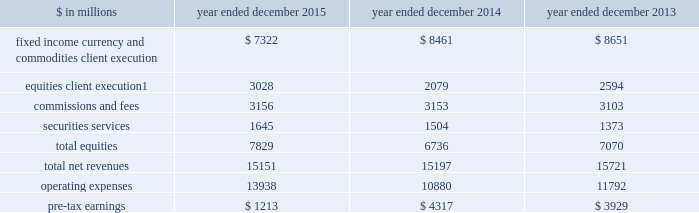The goldman sachs group , inc .
And subsidiaries management 2019s discussion and analysis equities .
Includes client execution activities related to making markets in equity products and commissions and fees from executing and clearing institutional client transactions on major stock , options and futures exchanges worldwide , as well as otc transactions .
Equities also includes our securities services business , which provides financing , securities lending and other prime brokerage services to institutional clients , including hedge funds , mutual funds , pension funds and foundations , and generates revenues primarily in the form of interest rate spreads or fees .
The table below presents the operating results of our institutional client services segment. .
Net revenues related to the americas reinsurance business were $ 317 million for 2013 .
In april 2013 , we completed the sale of a majority stake in our americas reinsurance business and no longer consolidate this business .
2015 versus 2014 .
Net revenues in institutional client services were $ 15.15 billion for 2015 , essentially unchanged compared with 2014 .
Net revenues in fixed income , currency and commodities client execution were $ 7.32 billion for 2015 , 13% ( 13 % ) lower than 2014 .
Excluding a gain of $ 168 million in 2014 related to the extinguishment of certain of our junior subordinated debt , net revenues in fixed income , currency and commodities client execution were 12% ( 12 % ) lower than 2014 , reflecting significantly lower net revenues in mortgages , credit products and commodities .
The decreases in mortgages and credit products reflected challenging market-making conditions and generally low levels of activity during 2015 .
The decline in commodities primarily reflected less favorable market-making conditions compared with 2014 , which included a strong first quarter of 2014 .
These decreases were partially offset by significantly higher net revenues in interest rate products and currencies , reflecting higher volatility levels which contributed to higher client activity levels , particularly during the first quarter of 2015 .
Net revenues in equities were $ 7.83 billion for 2015 , 16% ( 16 % ) higher than 2014 .
Excluding a gain of $ 121 million ( $ 30 million and $ 91 million included in equities client execution and securities services , respectively ) in 2014 related to the extinguishment of certain of our junior subordinated debt , net revenues in equities were 18% ( 18 % ) higher than 2014 , primarily due to significantly higher net revenues in equities client execution across the major regions , reflecting significantly higher results in both derivatives and cash products , and higher net revenues in securities services , reflecting the impact of higher average customer balances and improved securities lending spreads .
Commissions and fees were essentially unchanged compared with 2014 .
The firm elects the fair value option for certain unsecured borrowings .
The fair value net gain attributable to the impact of changes in our credit spreads on these borrowings was $ 255 million ( $ 214 million and $ 41 million related to fixed income , currency and commodities client execution and equities client execution , respectively ) for 2015 , compared with a net gain of $ 144 million ( $ 108 million and $ 36 million related to fixed income , currency and commodities client execution and equities client execution , respectively ) for 2014 .
During 2015 , the operating environment for institutional client services was positively impacted by diverging central bank monetary policies in the united states and the euro area in the first quarter , as increased volatility levels contributed to strong client activity levels in currencies , interest rate products and equity products , and market- making conditions improved .
However , during the remainder of the year , concerns about global growth and uncertainty about the u.s .
Federal reserve 2019s interest rate policy , along with lower global equity prices , widening high-yield credit spreads and declining commodity prices , contributed to lower levels of client activity , particularly in mortgages and credit , and more difficult market-making conditions .
If macroeconomic concerns continue over the long term and activity levels decline , net revenues in institutional client services would likely be negatively impacted .
Operating expenses were $ 13.94 billion for 2015 , 28% ( 28 % ) higher than 2014 , due to significantly higher net provisions for mortgage-related litigation and regulatory matters , partially offset by decreased compensation and benefits expenses .
Pre-tax earnings were $ 1.21 billion in 2015 , 72% ( 72 % ) lower than 2014 .
62 goldman sachs 2015 form 10-k .
What percentage of total net revenues in the institutional client services segment was due to fixed income currency and commodities client execution in 2014? 
Computations: (8461 / 15197)
Answer: 0.55675. The goldman sachs group , inc .
And subsidiaries management 2019s discussion and analysis equities .
Includes client execution activities related to making markets in equity products and commissions and fees from executing and clearing institutional client transactions on major stock , options and futures exchanges worldwide , as well as otc transactions .
Equities also includes our securities services business , which provides financing , securities lending and other prime brokerage services to institutional clients , including hedge funds , mutual funds , pension funds and foundations , and generates revenues primarily in the form of interest rate spreads or fees .
The table below presents the operating results of our institutional client services segment. .
Net revenues related to the americas reinsurance business were $ 317 million for 2013 .
In april 2013 , we completed the sale of a majority stake in our americas reinsurance business and no longer consolidate this business .
2015 versus 2014 .
Net revenues in institutional client services were $ 15.15 billion for 2015 , essentially unchanged compared with 2014 .
Net revenues in fixed income , currency and commodities client execution were $ 7.32 billion for 2015 , 13% ( 13 % ) lower than 2014 .
Excluding a gain of $ 168 million in 2014 related to the extinguishment of certain of our junior subordinated debt , net revenues in fixed income , currency and commodities client execution were 12% ( 12 % ) lower than 2014 , reflecting significantly lower net revenues in mortgages , credit products and commodities .
The decreases in mortgages and credit products reflected challenging market-making conditions and generally low levels of activity during 2015 .
The decline in commodities primarily reflected less favorable market-making conditions compared with 2014 , which included a strong first quarter of 2014 .
These decreases were partially offset by significantly higher net revenues in interest rate products and currencies , reflecting higher volatility levels which contributed to higher client activity levels , particularly during the first quarter of 2015 .
Net revenues in equities were $ 7.83 billion for 2015 , 16% ( 16 % ) higher than 2014 .
Excluding a gain of $ 121 million ( $ 30 million and $ 91 million included in equities client execution and securities services , respectively ) in 2014 related to the extinguishment of certain of our junior subordinated debt , net revenues in equities were 18% ( 18 % ) higher than 2014 , primarily due to significantly higher net revenues in equities client execution across the major regions , reflecting significantly higher results in both derivatives and cash products , and higher net revenues in securities services , reflecting the impact of higher average customer balances and improved securities lending spreads .
Commissions and fees were essentially unchanged compared with 2014 .
The firm elects the fair value option for certain unsecured borrowings .
The fair value net gain attributable to the impact of changes in our credit spreads on these borrowings was $ 255 million ( $ 214 million and $ 41 million related to fixed income , currency and commodities client execution and equities client execution , respectively ) for 2015 , compared with a net gain of $ 144 million ( $ 108 million and $ 36 million related to fixed income , currency and commodities client execution and equities client execution , respectively ) for 2014 .
During 2015 , the operating environment for institutional client services was positively impacted by diverging central bank monetary policies in the united states and the euro area in the first quarter , as increased volatility levels contributed to strong client activity levels in currencies , interest rate products and equity products , and market- making conditions improved .
However , during the remainder of the year , concerns about global growth and uncertainty about the u.s .
Federal reserve 2019s interest rate policy , along with lower global equity prices , widening high-yield credit spreads and declining commodity prices , contributed to lower levels of client activity , particularly in mortgages and credit , and more difficult market-making conditions .
If macroeconomic concerns continue over the long term and activity levels decline , net revenues in institutional client services would likely be negatively impacted .
Operating expenses were $ 13.94 billion for 2015 , 28% ( 28 % ) higher than 2014 , due to significantly higher net provisions for mortgage-related litigation and regulatory matters , partially offset by decreased compensation and benefits expenses .
Pre-tax earnings were $ 1.21 billion in 2015 , 72% ( 72 % ) lower than 2014 .
62 goldman sachs 2015 form 10-k .
In millions for 2015 , 2014 and 2013 , what was total commissions and fees? 
Computations: table_sum(commissions and fees, none)
Answer: 9412.0. 